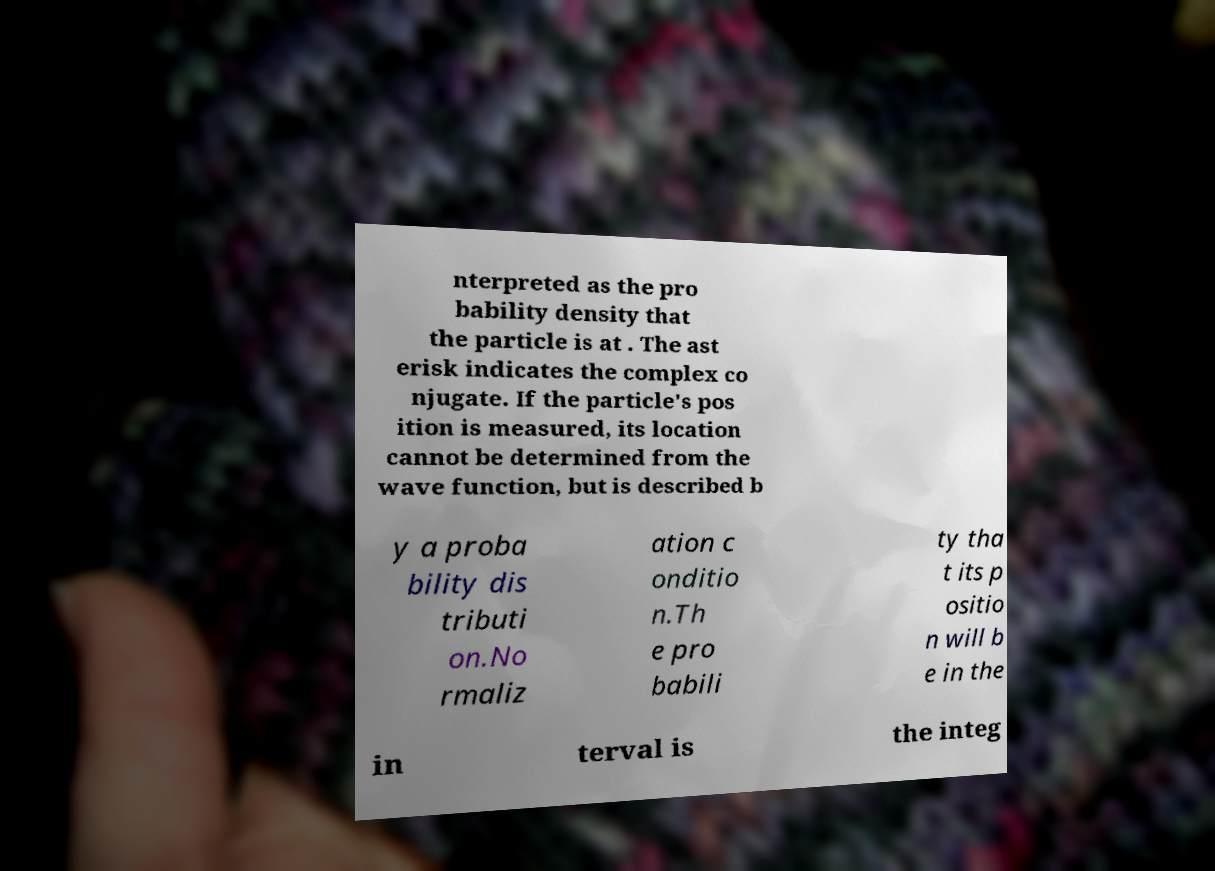Can you read and provide the text displayed in the image?This photo seems to have some interesting text. Can you extract and type it out for me? nterpreted as the pro bability density that the particle is at . The ast erisk indicates the complex co njugate. If the particle's pos ition is measured, its location cannot be determined from the wave function, but is described b y a proba bility dis tributi on.No rmaliz ation c onditio n.Th e pro babili ty tha t its p ositio n will b e in the in terval is the integ 